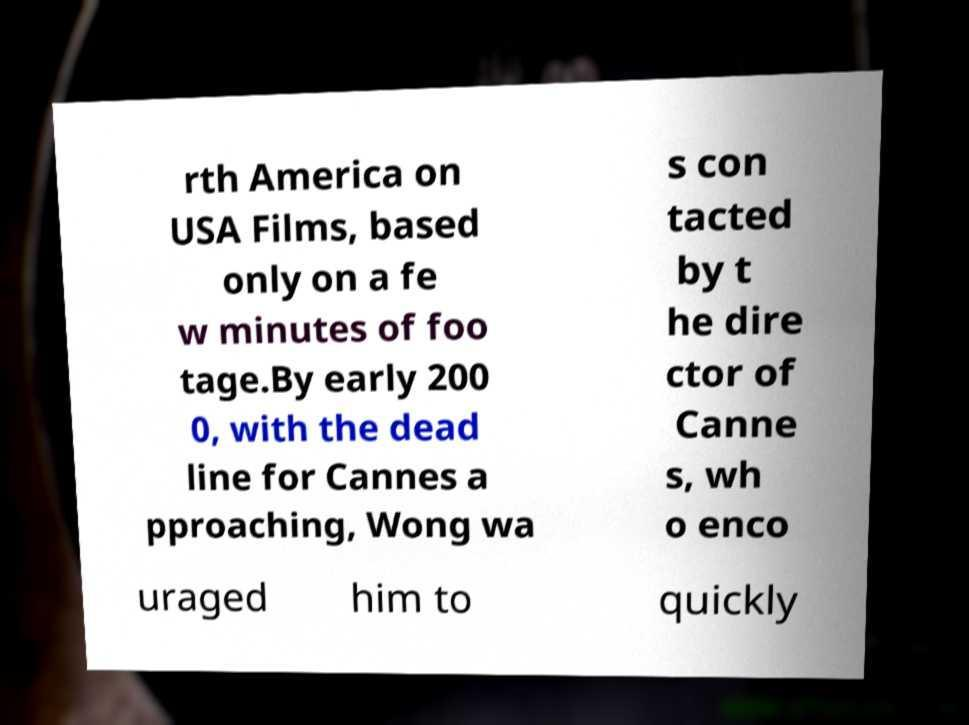Please identify and transcribe the text found in this image. rth America on USA Films, based only on a fe w minutes of foo tage.By early 200 0, with the dead line for Cannes a pproaching, Wong wa s con tacted by t he dire ctor of Canne s, wh o enco uraged him to quickly 